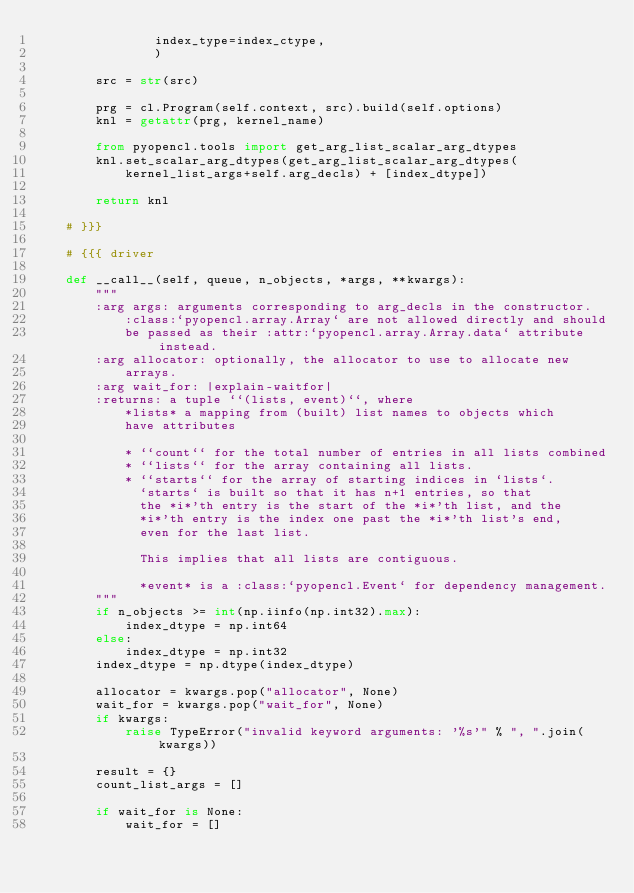<code> <loc_0><loc_0><loc_500><loc_500><_Python_>                index_type=index_ctype,
                )

        src = str(src)

        prg = cl.Program(self.context, src).build(self.options)
        knl = getattr(prg, kernel_name)

        from pyopencl.tools import get_arg_list_scalar_arg_dtypes
        knl.set_scalar_arg_dtypes(get_arg_list_scalar_arg_dtypes(
            kernel_list_args+self.arg_decls) + [index_dtype])

        return knl

    # }}}

    # {{{ driver

    def __call__(self, queue, n_objects, *args, **kwargs):
        """
        :arg args: arguments corresponding to arg_decls in the constructor.
            :class:`pyopencl.array.Array` are not allowed directly and should
            be passed as their :attr:`pyopencl.array.Array.data` attribute instead.
        :arg allocator: optionally, the allocator to use to allocate new
            arrays.
        :arg wait_for: |explain-waitfor|
        :returns: a tuple ``(lists, event)``, where
            *lists* a mapping from (built) list names to objects which
            have attributes

            * ``count`` for the total number of entries in all lists combined
            * ``lists`` for the array containing all lists.
            * ``starts`` for the array of starting indices in `lists`.
              `starts` is built so that it has n+1 entries, so that
              the *i*'th entry is the start of the *i*'th list, and the
              *i*'th entry is the index one past the *i*'th list's end,
              even for the last list.

              This implies that all lists are contiguous.

              *event* is a :class:`pyopencl.Event` for dependency management.
        """
        if n_objects >= int(np.iinfo(np.int32).max):
            index_dtype = np.int64
        else:
            index_dtype = np.int32
        index_dtype = np.dtype(index_dtype)

        allocator = kwargs.pop("allocator", None)
        wait_for = kwargs.pop("wait_for", None)
        if kwargs:
            raise TypeError("invalid keyword arguments: '%s'" % ", ".join(kwargs))

        result = {}
        count_list_args = []

        if wait_for is None:
            wait_for = []
</code> 